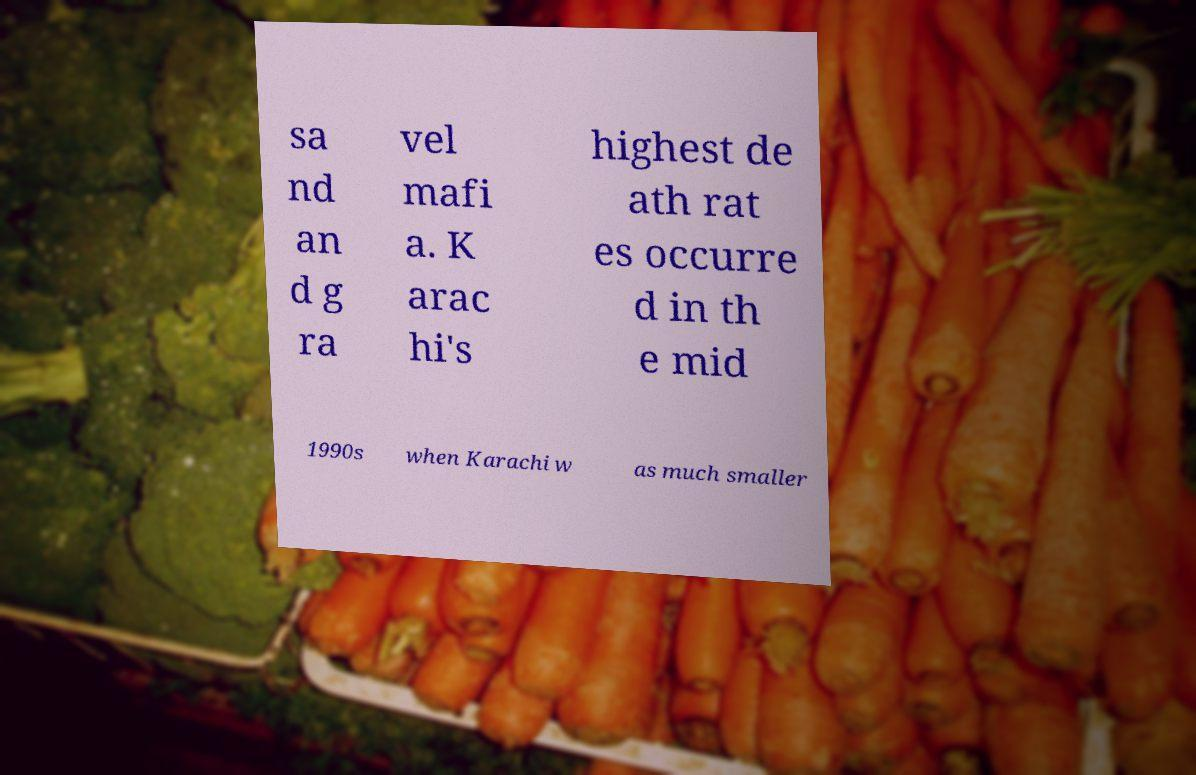Can you accurately transcribe the text from the provided image for me? sa nd an d g ra vel mafi a. K arac hi's highest de ath rat es occurre d in th e mid 1990s when Karachi w as much smaller 